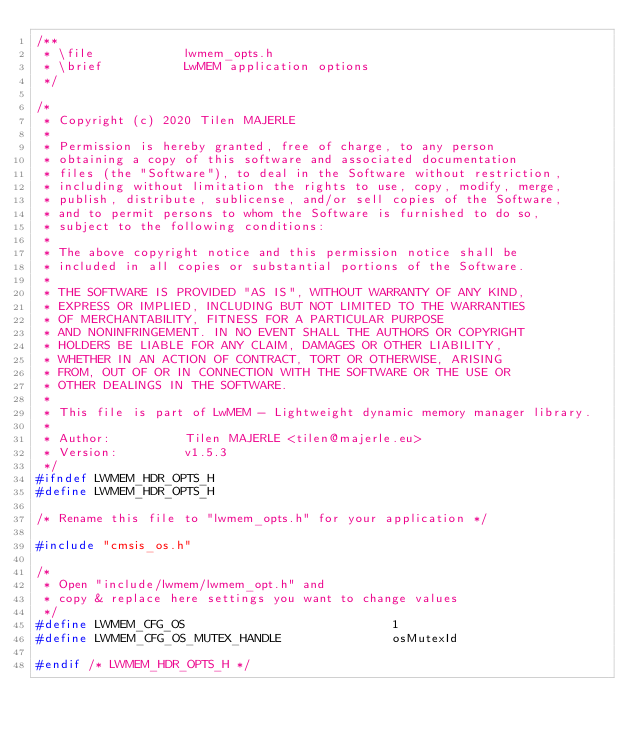<code> <loc_0><loc_0><loc_500><loc_500><_C_>/**
 * \file            lwmem_opts.h
 * \brief           LwMEM application options
 */

/*
 * Copyright (c) 2020 Tilen MAJERLE
 *
 * Permission is hereby granted, free of charge, to any person
 * obtaining a copy of this software and associated documentation
 * files (the "Software"), to deal in the Software without restriction,
 * including without limitation the rights to use, copy, modify, merge,
 * publish, distribute, sublicense, and/or sell copies of the Software,
 * and to permit persons to whom the Software is furnished to do so,
 * subject to the following conditions:
 *
 * The above copyright notice and this permission notice shall be
 * included in all copies or substantial portions of the Software.
 *
 * THE SOFTWARE IS PROVIDED "AS IS", WITHOUT WARRANTY OF ANY KIND,
 * EXPRESS OR IMPLIED, INCLUDING BUT NOT LIMITED TO THE WARRANTIES
 * OF MERCHANTABILITY, FITNESS FOR A PARTICULAR PURPOSE
 * AND NONINFRINGEMENT. IN NO EVENT SHALL THE AUTHORS OR COPYRIGHT
 * HOLDERS BE LIABLE FOR ANY CLAIM, DAMAGES OR OTHER LIABILITY,
 * WHETHER IN AN ACTION OF CONTRACT, TORT OR OTHERWISE, ARISING
 * FROM, OUT OF OR IN CONNECTION WITH THE SOFTWARE OR THE USE OR
 * OTHER DEALINGS IN THE SOFTWARE.
 *
 * This file is part of LwMEM - Lightweight dynamic memory manager library.
 *
 * Author:          Tilen MAJERLE <tilen@majerle.eu>
 * Version:         v1.5.3
 */
#ifndef LWMEM_HDR_OPTS_H
#define LWMEM_HDR_OPTS_H

/* Rename this file to "lwmem_opts.h" for your application */

#include "cmsis_os.h"

/*
 * Open "include/lwmem/lwmem_opt.h" and
 * copy & replace here settings you want to change values
 */
#define LWMEM_CFG_OS                            1
#define LWMEM_CFG_OS_MUTEX_HANDLE               osMutexId

#endif /* LWMEM_HDR_OPTS_H */
</code> 